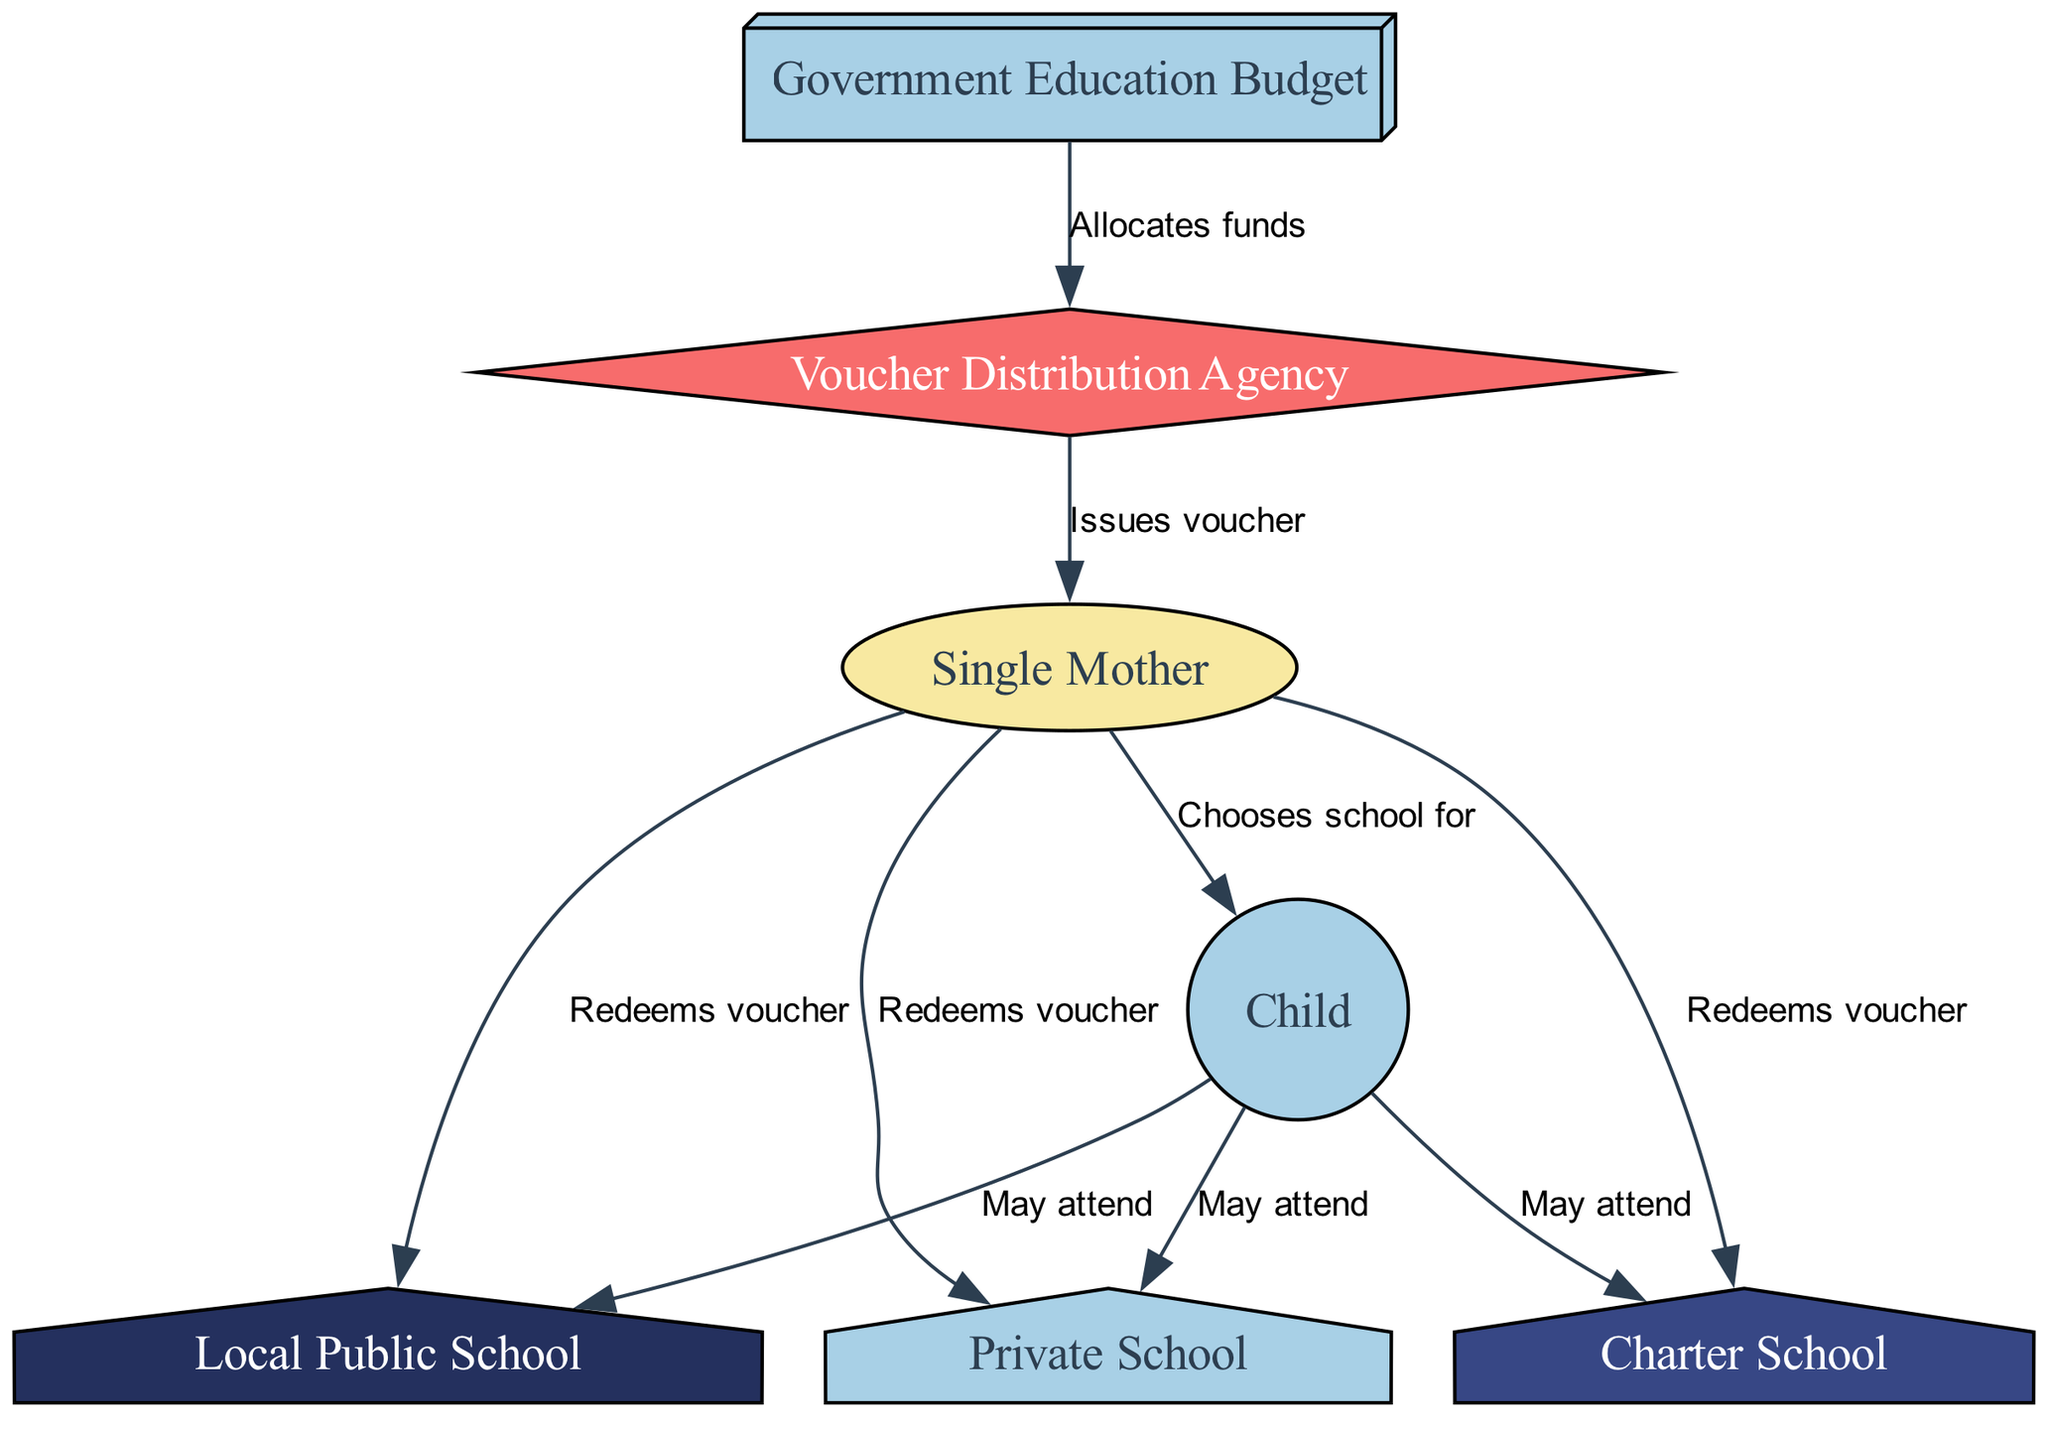What is the first source of funding shown in the diagram? The diagram starts with the "Government Education Budget" as the first node from which the funding flows. It is indicated that the government allocates funds to the voucher distribution agency.
Answer: Government Education Budget How many school options can a child attend according to the diagram? The diagram shows three school options available for a child to attend: Local Public School, Charter School, and Private School. Therefore, there are a total of three options.
Answer: Three Who issues the educational voucher in the flow diagram? The "Voucher Distribution Agency" is responsible for issuing the educational voucher to the parent, as indicated by the arrow flowing from the agency to the parent node.
Answer: Voucher Distribution Agency Which entity redeems the voucher for the child? In the diagram, the "Parent" has the role of redeeming the voucher for the child. The flow indicates that the parent can redeem it for any of the school options available.
Answer: Parent What connections exist between the child and the available schools? The child can potentially attend a Local Public School, Charter School, and Private School, as shown by three arrows emanating from the child node pointing towards each school type, indicating the relationship.
Answer: Public School, Charter School, Private School What is the relationship between the government and the voucher distribution agency? The relationship is characterized by the government allocating funds to the voucher distribution agency, represented in the diagram by an arrow from the "Government Education Budget" node to the "Voucher Distribution Agency" node labeled "Allocates funds."
Answer: Allocates funds If a parent chooses a private school, what is the process depicted in the diagram? The process illustrated in the diagram shows the parent receiving the voucher from the voucher distribution agency. Then, the parent redeems the voucher to enroll the child in a private school, as indicated by the connected edges between these nodes.
Answer: Redeems voucher How many edges connect the parent to different school options? The parent is connected to all three school types via three edges: one each for the Local Public School, Charter School, and Private School. Thus, there are three edges connecting the parent to these schools.
Answer: Three What does the child have to do before attending school according to the diagram? The diagram indicates that the child does not directly attend a school but first requires a selection made by the parent, as the arrow describes that the parent chooses the school for the child.
Answer: Chooses school for What shape is used for the voucher distribution agency in the diagram? The voucher distribution agency is represented as a diamond shape, which is a specific visual cue that differentiates it from other nodes in the diagram.
Answer: Diamond 